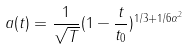<formula> <loc_0><loc_0><loc_500><loc_500>a ( t ) = \frac { 1 } { \sqrt { T } } ( 1 - \frac { t } { t _ { 0 } } ) ^ { 1 / 3 + 1 / 6 \alpha ^ { 2 } }</formula> 